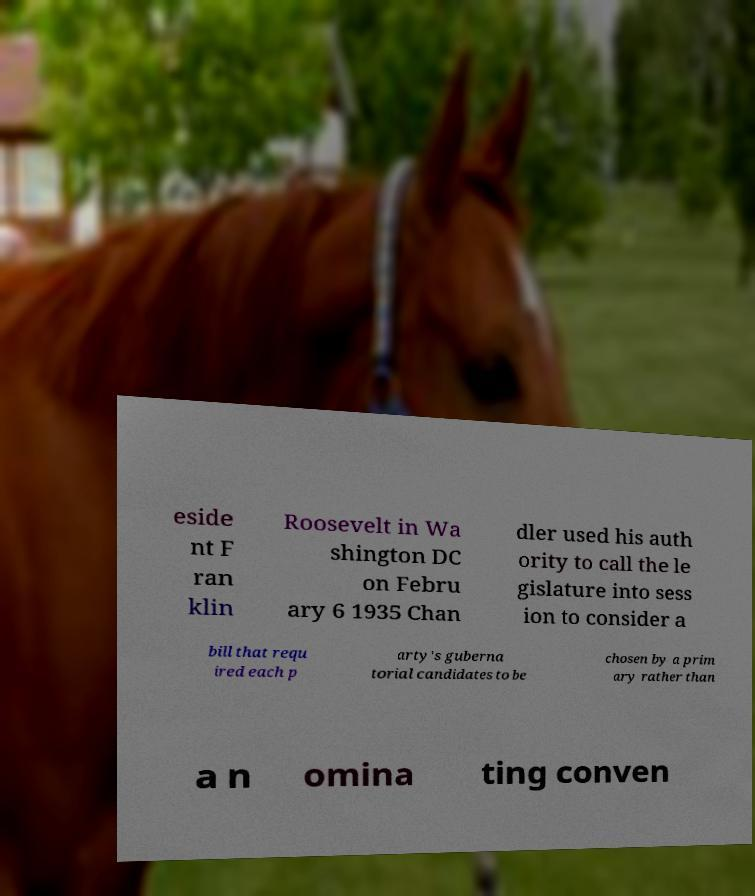Please identify and transcribe the text found in this image. eside nt F ran klin Roosevelt in Wa shington DC on Febru ary 6 1935 Chan dler used his auth ority to call the le gislature into sess ion to consider a bill that requ ired each p arty's guberna torial candidates to be chosen by a prim ary rather than a n omina ting conven 